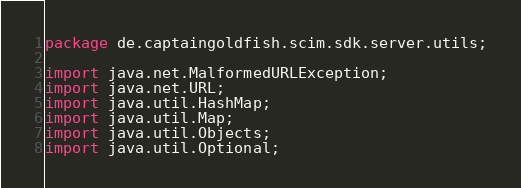Convert code to text. <code><loc_0><loc_0><loc_500><loc_500><_Java_>package de.captaingoldfish.scim.sdk.server.utils;

import java.net.MalformedURLException;
import java.net.URL;
import java.util.HashMap;
import java.util.Map;
import java.util.Objects;
import java.util.Optional;</code> 